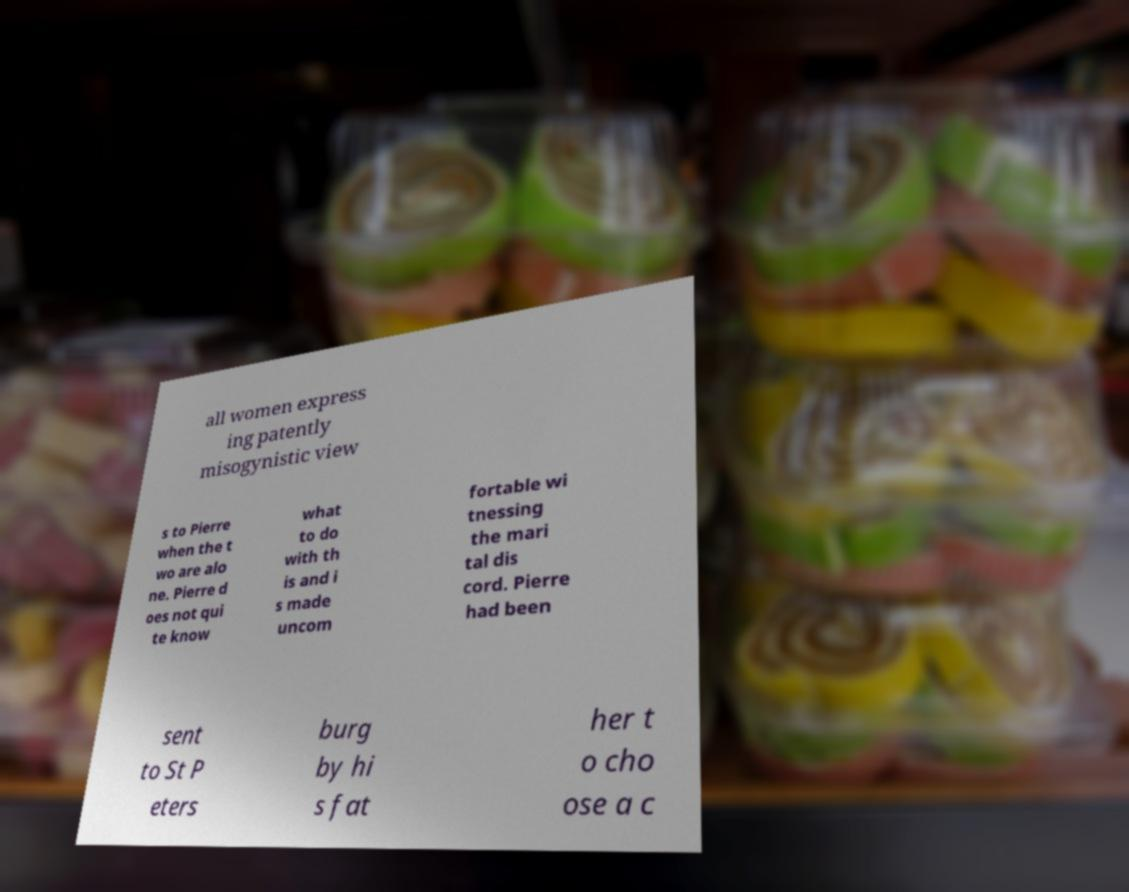Please identify and transcribe the text found in this image. all women express ing patently misogynistic view s to Pierre when the t wo are alo ne. Pierre d oes not qui te know what to do with th is and i s made uncom fortable wi tnessing the mari tal dis cord. Pierre had been sent to St P eters burg by hi s fat her t o cho ose a c 